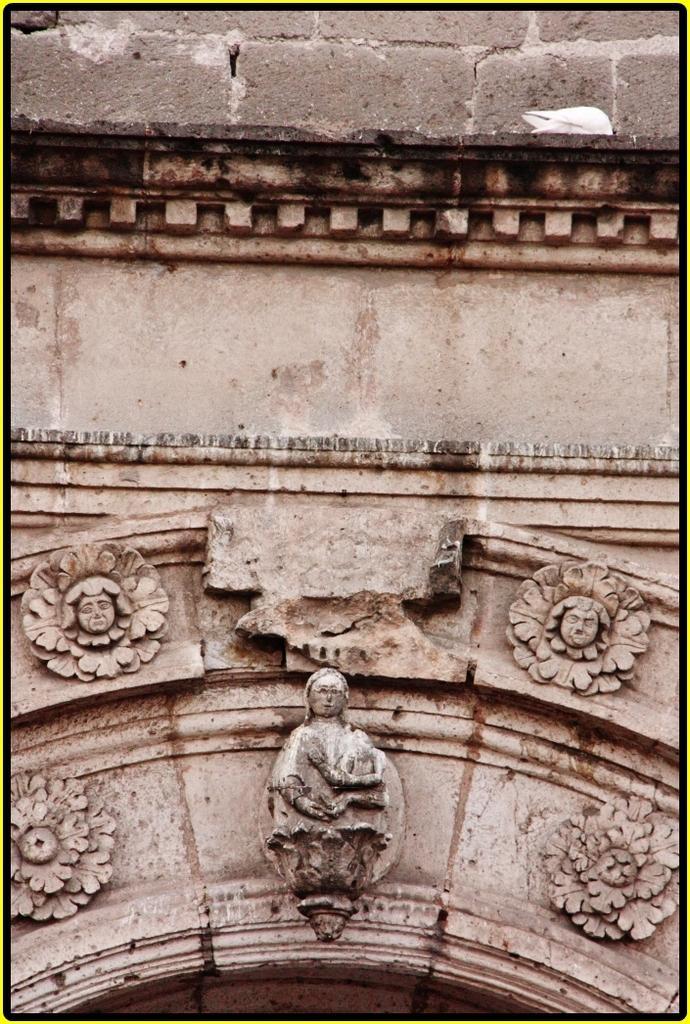Please provide a concise description of this image. In this picture we can see sculptures on the wall. 